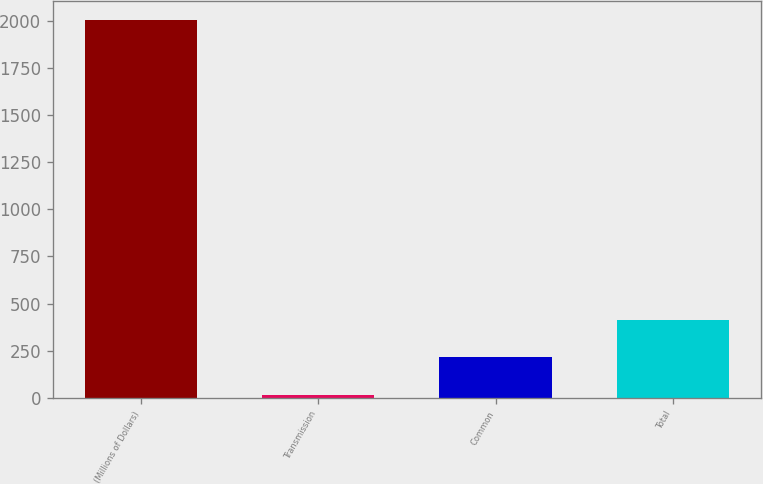Convert chart. <chart><loc_0><loc_0><loc_500><loc_500><bar_chart><fcel>(Millions of Dollars)<fcel>Transmission<fcel>Common<fcel>Total<nl><fcel>2003<fcel>17<fcel>215.6<fcel>414.2<nl></chart> 